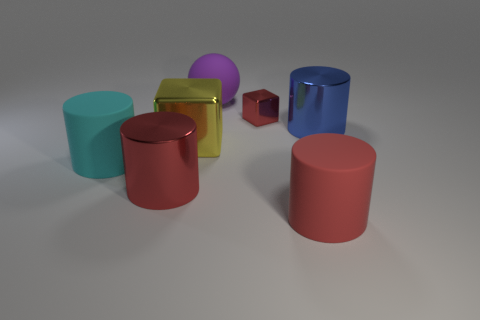There is a large matte cylinder to the right of the tiny thing that is to the right of the matte sphere; what is its color? red 